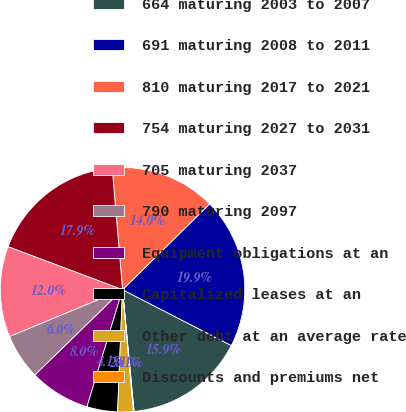<chart> <loc_0><loc_0><loc_500><loc_500><pie_chart><fcel>664 maturing 2003 to 2007<fcel>691 maturing 2008 to 2011<fcel>810 maturing 2017 to 2021<fcel>754 maturing 2027 to 2031<fcel>705 maturing 2037<fcel>790 maturing 2097<fcel>Equipment obligations at an<fcel>Capitalized leases at an<fcel>Other debt at an average rate<fcel>Discounts and premiums net<nl><fcel>15.95%<fcel>19.92%<fcel>13.97%<fcel>17.93%<fcel>11.98%<fcel>6.03%<fcel>8.02%<fcel>4.05%<fcel>2.07%<fcel>0.08%<nl></chart> 